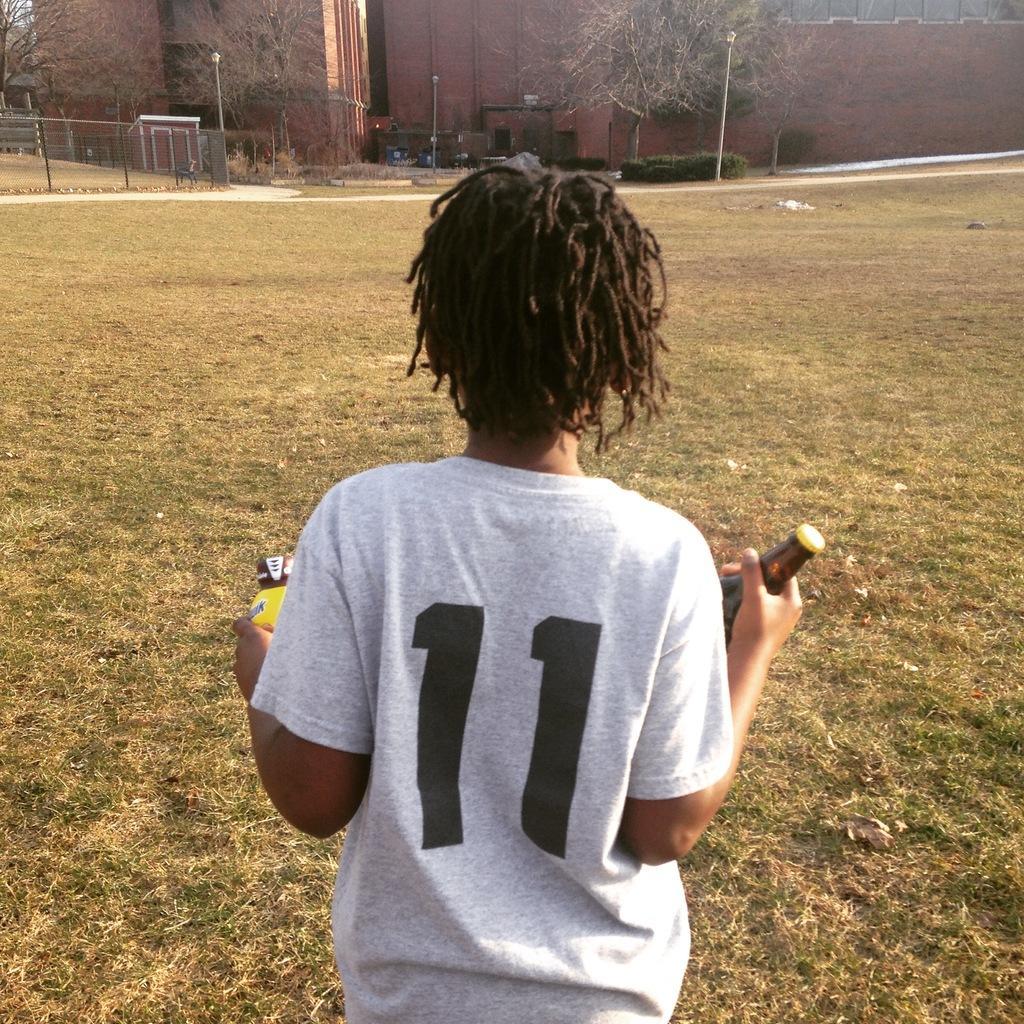How would you summarize this image in a sentence or two? In this picture a boy is holding a bottle in his hand, in front of him we can find couple of poles, fence, trees and buildings. 